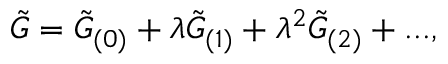Convert formula to latex. <formula><loc_0><loc_0><loc_500><loc_500>\tilde { G } = \tilde { G } _ { ( 0 ) } + \lambda \tilde { G } _ { ( 1 ) } + \lambda ^ { 2 } \tilde { G } _ { ( 2 ) } + \dots ,</formula> 